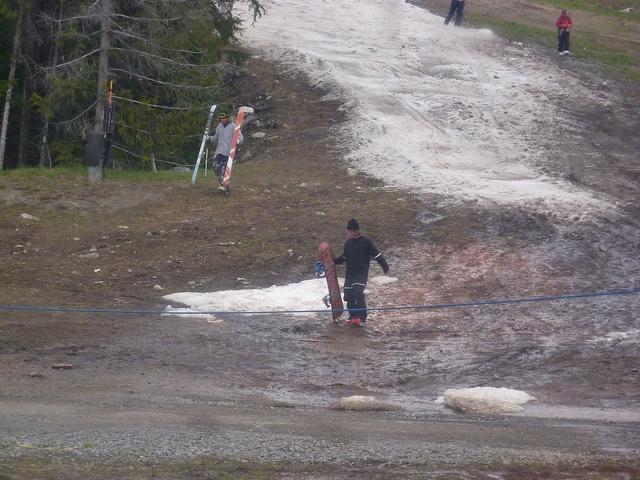What is the man doing?
Answer briefly. Walking. Where is the water coming from?
Keep it brief. Melting snow. Is the water in the street from rain?
Write a very short answer. No. What season is depicted?
Concise answer only. Winter. What is being poured?
Answer briefly. Nothing. What is this guy doing?
Keep it brief. Walking. Is it high or low tide?
Short answer required. High. What are they doing?
Give a very brief answer. Walking. What are the people wearing?
Short answer required. Winter clothes. Is there any water in the picture?
Be succinct. Yes. What is the person on the water wearing?
Short answer required. Snowsuit. What are the people holding?
Answer briefly. Snowboards. 